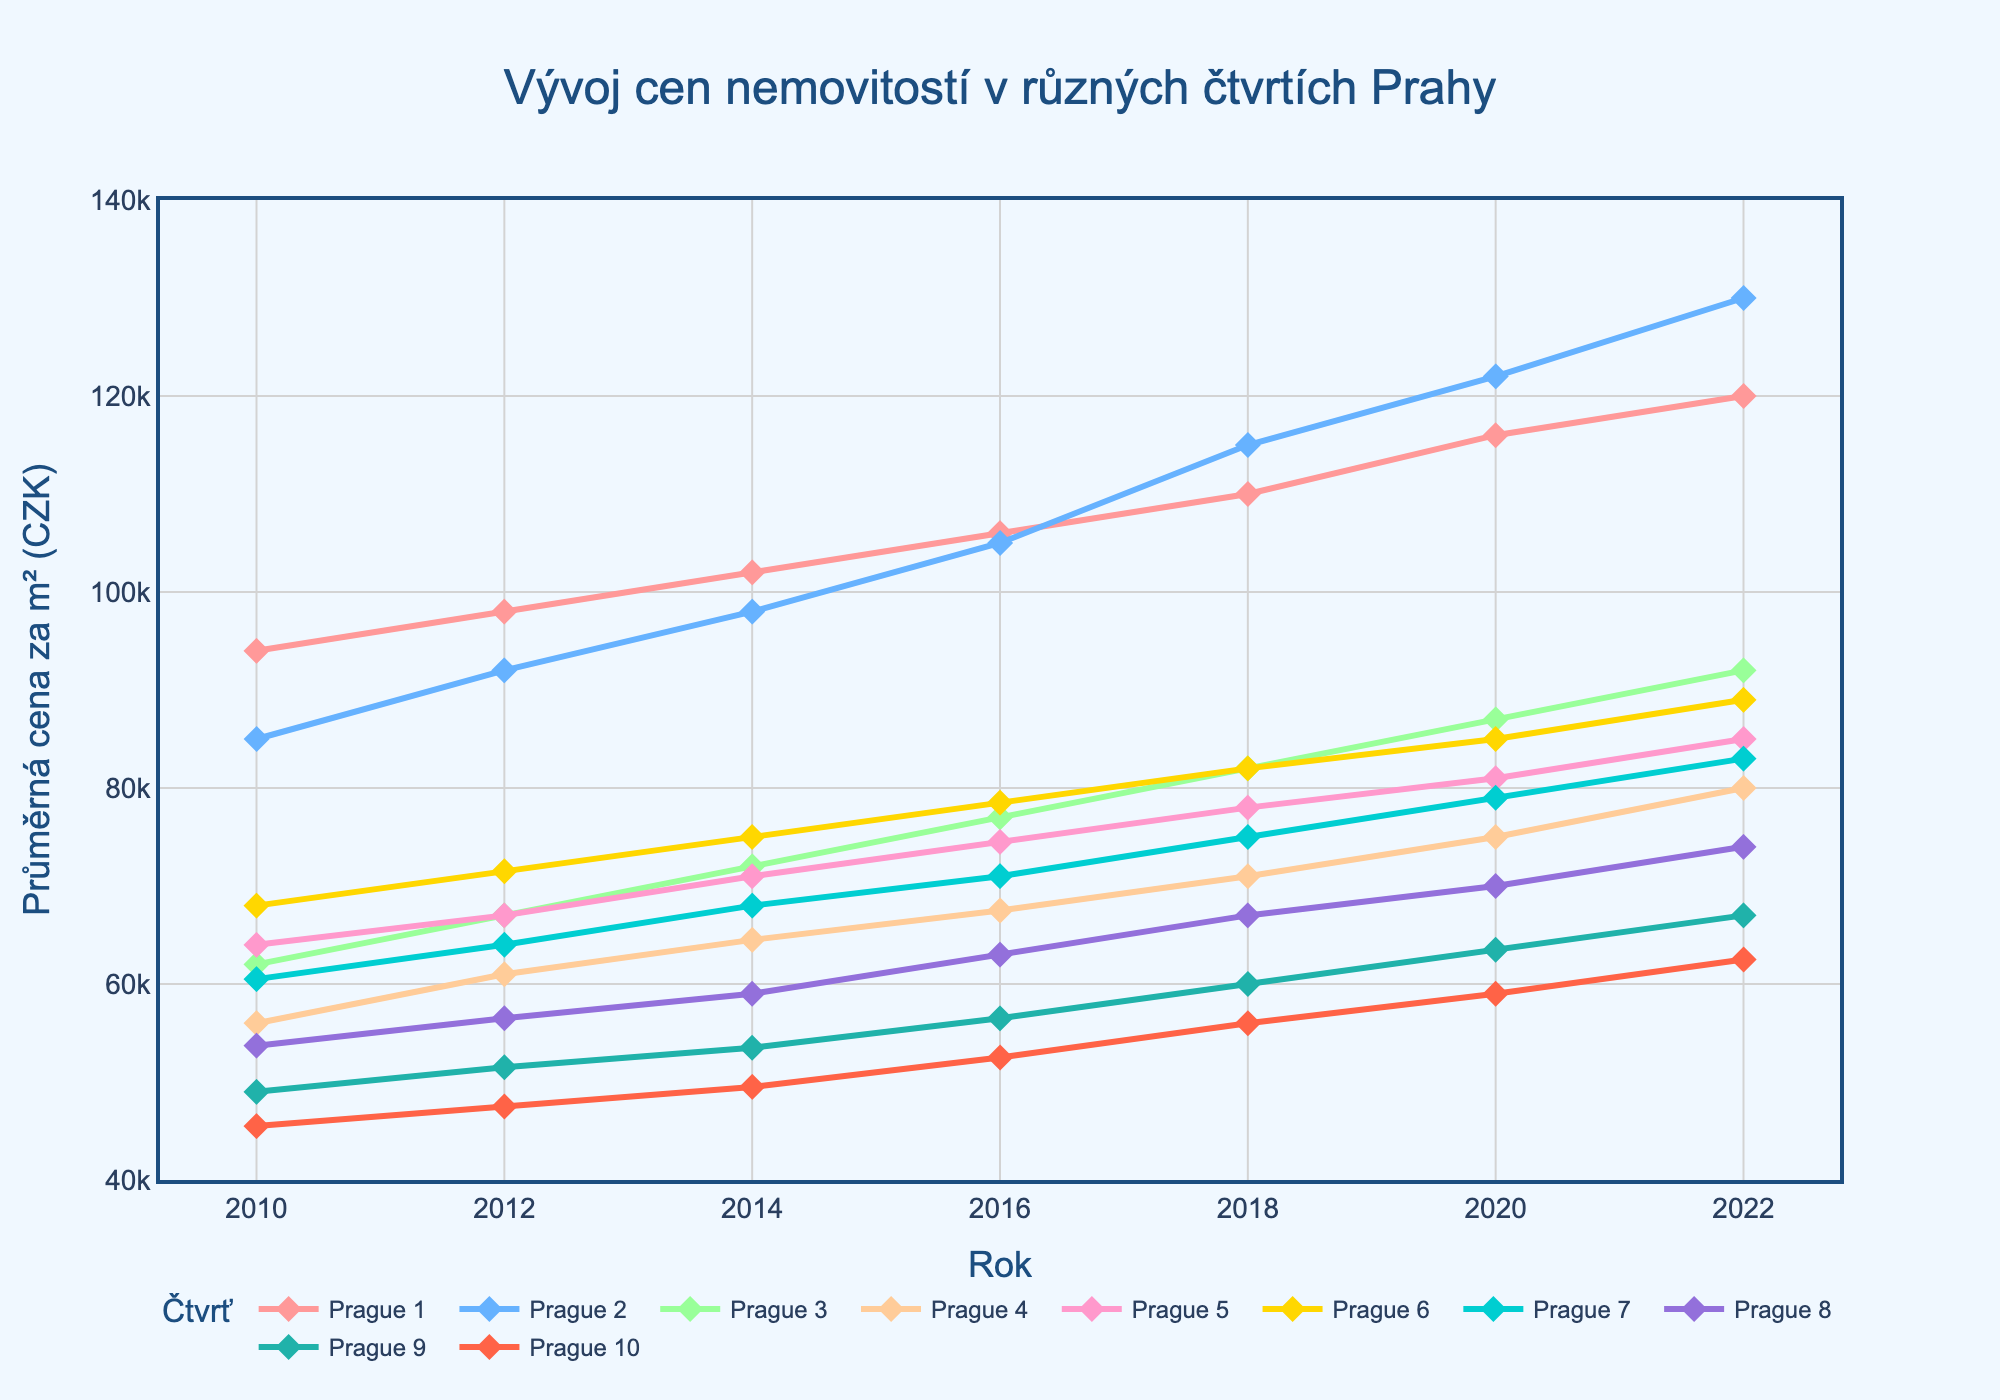What's the title of the plot? The title is located at the top center of the plot. By reading it, we can determine the title.
Answer: Vývoj cen nemovitostí v různých čtvrtích Prahy What is displayed on the x-axis? The x-axis label is located below the x-axis line.
Answer: Rok What is the average price per sqm in Prague 1 in 2022? The data for Prague 1 shows a rising trend annually until 2022. At this point, the value is identifiable on the y-axis.
Answer: 120000 CZK Which district had the highest average price per sqm in 2010? By looking at the values corresponding to the different districts for the year 2010, we can identify which district has the highest price.
Answer: Prague 1 What is the trend of real estate prices in Prague 2 from 2010 to 2022? Observing the line tracing Prague 2 from 2010 to 2022 shows a continuous increase without any significant drops.
Answer: Increasing Which district saw the most significant increase in average price per sqm between 2010 and 2022? By comparing the values from 2010 and 2022 for each district, one can calculate the increase for each and determine the greatest one. Prague 2 increased from 85000 to 130000, which is the highest.
Answer: Prague 2 Compare the average prices per sqm in Prague 4 and Prague 10 in 2020. Which is higher? Locate the points for Prague 4 and Prague 10 in 2020, then compare the y-axis values.
Answer: Prague 4 What is the general trend of real estate prices across all districts from 2010 to 2022? Observing the entire set of lines from 2010 to 2022 shows that all are trending upwards, indicating an overall increase.
Answer: Increasing Did any district experience a decrease in average price per sqm at any point between 2010 and 2022? Look at the individual lines for each district. Since all are ascending with no dips, none experienced a decrease.
Answer: No Which district had the least expensive average price per sqm in 2022? Identify the lowest value point among the districts in 2022 and note the corresponding district.
Answer: Prague 10 